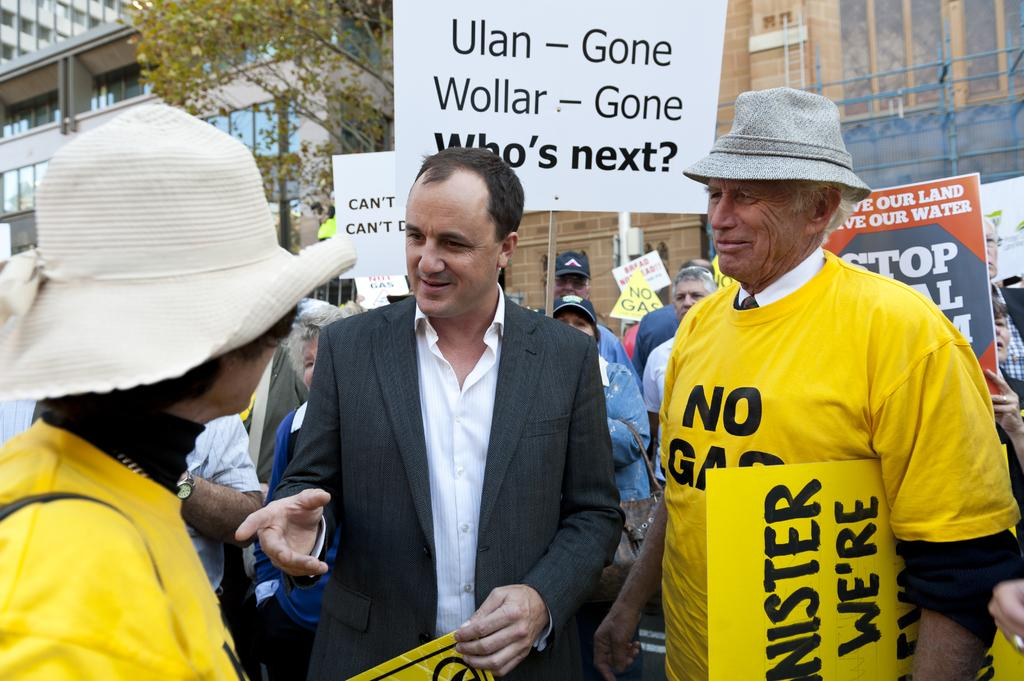How many people are present in the image? There are people in the image, but the exact number is not specified. What type of clothing are some people wearing? Some people are wearing t-shirts and caps. What are some people holding in their hands? Some people are holding boards in their hands. What can be seen in the background of the image? There are trees, buildings, and poles in the background of the image. Can you see an owl perched on one of the poles in the background? No, there is no owl present in the image. What type of bait is being used by the people holding boards in their hands? There is no mention of bait or fishing in the image; the people are holding boards. 